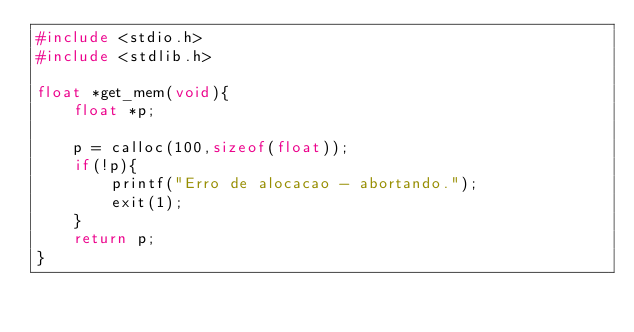Convert code to text. <code><loc_0><loc_0><loc_500><loc_500><_C_>#include <stdio.h>
#include <stdlib.h>

float *get_mem(void){
    float *p;

    p = calloc(100,sizeof(float));
    if(!p){
        printf("Erro de alocacao - abortando.");
        exit(1);
    }
    return p;
}
</code> 